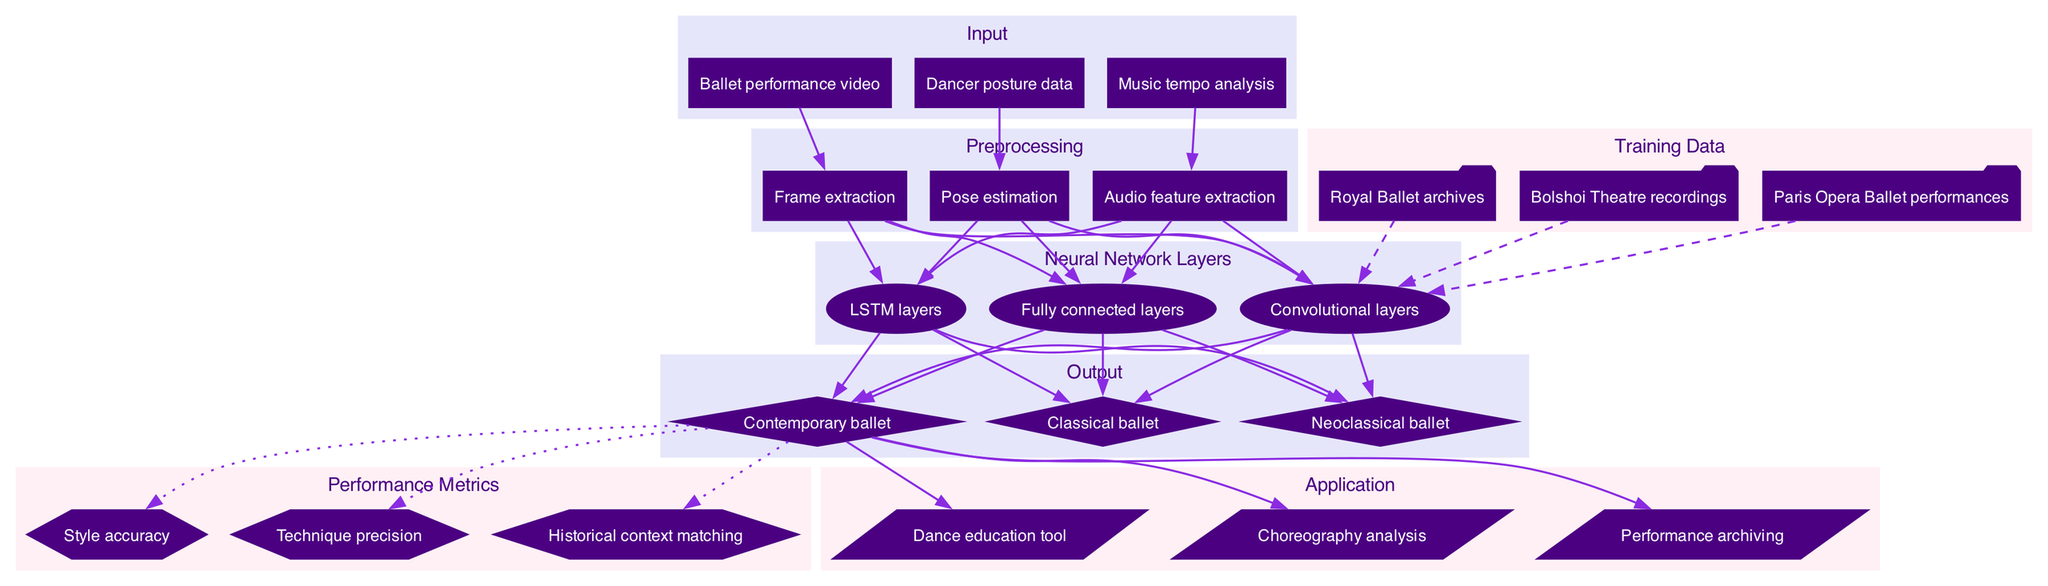What's the first item in the input layer? The diagram specifies that the first item in the input layer is "Ballet performance video." As the diagram structure shows an ordered list, it is clear from the labeling that this is the first input.
Answer: Ballet performance video How many output categories are there? The output layer distinctly lists three categories: "Classical ballet," "Neoclassical ballet," and "Contemporary ballet." By counting these categories visually, we can determine that there are three outputs.
Answer: Three What type of layer comes after preprocessing? According to the diagram flow, the preprocessing layer feeds directly into the neural network layers, indicating that the next type of layer is "Neural Network Layers." This can be inferred from the directional edges connecting the two components.
Answer: Neural Network Layers Which training data source includes performances from Russia? The training data lists "Bolshoi Theatre recordings" as one of the sources, which is notably a prominent ballet institution located in Russia. Thus, it is evident that this source is related to performances from Russia.
Answer: Bolshoi Theatre recordings What is the output type connected to "Technique precision"? The "Technique precision" metric in the performance metrics section is connected specifically to the output "Contemporary ballet." By tracing the edge from the output to the metrics section, we can see this direct connection.
Answer: Contemporary ballet Which preprocessing method is used for audio analysis? The preprocessing step labeled "Audio feature extraction" is specifically used for analyzing the audio from the dance performances. This method is clearly stated in the preprocessing section.
Answer: Audio feature extraction How many nodes are in the neural network layers? There are three nodes listed under the neural network layers: "Convolutional layers," "LSTM layers," and "Fully connected layers." By counting these nodes, the total comes to three.
Answer: Three Which performance metric is focused on historical context? The performance metric labeled "Historical context matching" specifically addresses the historical aspect of dance styles and techniques, as indicated in the performance metrics section of the diagram.
Answer: Historical context matching What application is designed for performance analysis? The application labeled "Choreography analysis" is explicitly intended for analyzing dance performances. This is evident from the application nodes in the diagram.
Answer: Choreography analysis 